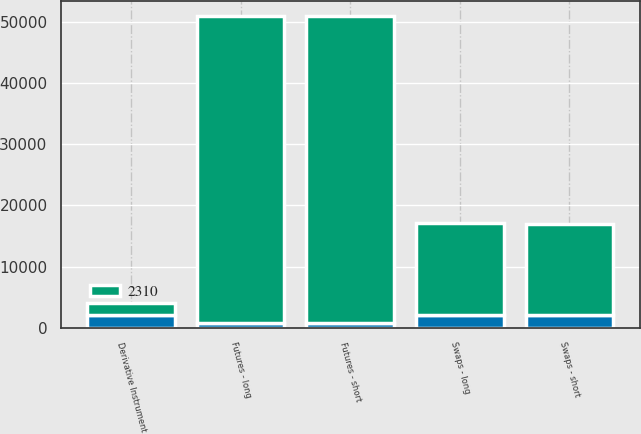Convert chart to OTSL. <chart><loc_0><loc_0><loc_500><loc_500><stacked_bar_chart><ecel><fcel>Derivative Instrument<fcel>Swaps - long<fcel>Swaps - short<fcel>Futures - long<fcel>Futures - short<nl><fcel>2310<fcel>2012<fcel>15128<fcel>14968<fcel>50126<fcel>50133<nl><fcel>nan<fcel>2013<fcel>2000<fcel>2000<fcel>825<fcel>825<nl></chart> 